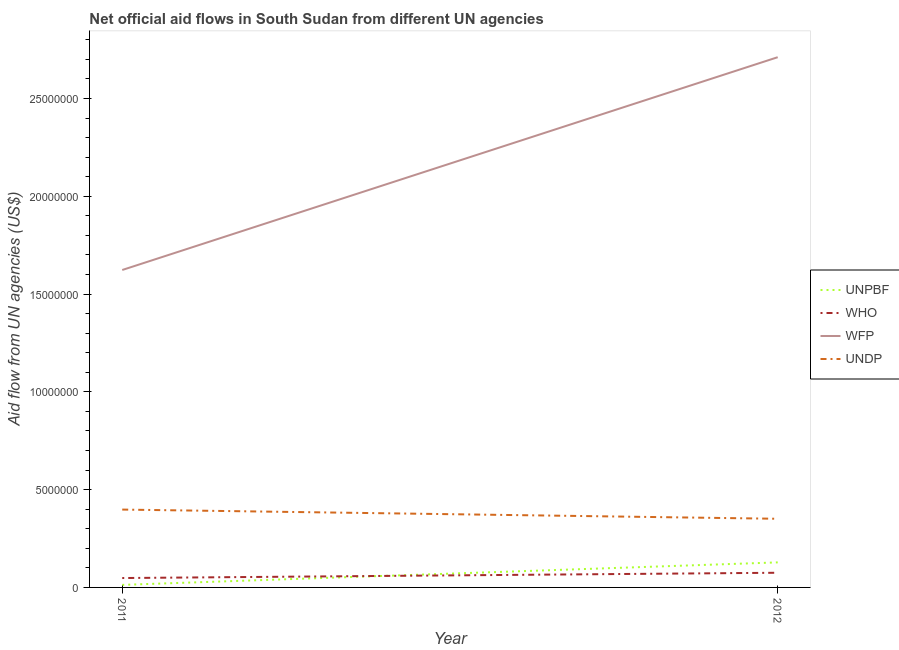How many different coloured lines are there?
Offer a very short reply. 4. What is the amount of aid given by undp in 2011?
Your answer should be very brief. 3.98e+06. Across all years, what is the maximum amount of aid given by unpbf?
Your answer should be very brief. 1.28e+06. Across all years, what is the minimum amount of aid given by who?
Offer a terse response. 4.80e+05. In which year was the amount of aid given by unpbf minimum?
Ensure brevity in your answer.  2011. What is the total amount of aid given by undp in the graph?
Provide a succinct answer. 7.49e+06. What is the difference between the amount of aid given by unpbf in 2011 and that in 2012?
Your response must be concise. -1.15e+06. What is the difference between the amount of aid given by unpbf in 2011 and the amount of aid given by wfp in 2012?
Your answer should be very brief. -2.70e+07. What is the average amount of aid given by unpbf per year?
Make the answer very short. 7.05e+05. In the year 2012, what is the difference between the amount of aid given by unpbf and amount of aid given by wfp?
Ensure brevity in your answer.  -2.58e+07. In how many years, is the amount of aid given by undp greater than 5000000 US$?
Your answer should be compact. 0. What is the ratio of the amount of aid given by undp in 2011 to that in 2012?
Your answer should be compact. 1.13. Does the amount of aid given by unpbf monotonically increase over the years?
Your response must be concise. Yes. Is the amount of aid given by unpbf strictly greater than the amount of aid given by wfp over the years?
Provide a succinct answer. No. Is the amount of aid given by unpbf strictly less than the amount of aid given by who over the years?
Your response must be concise. No. How many lines are there?
Ensure brevity in your answer.  4. How many years are there in the graph?
Your answer should be compact. 2. Does the graph contain any zero values?
Keep it short and to the point. No. Does the graph contain grids?
Ensure brevity in your answer.  No. Where does the legend appear in the graph?
Offer a very short reply. Center right. How many legend labels are there?
Your answer should be compact. 4. What is the title of the graph?
Offer a terse response. Net official aid flows in South Sudan from different UN agencies. What is the label or title of the Y-axis?
Make the answer very short. Aid flow from UN agencies (US$). What is the Aid flow from UN agencies (US$) of UNPBF in 2011?
Provide a succinct answer. 1.30e+05. What is the Aid flow from UN agencies (US$) of WHO in 2011?
Make the answer very short. 4.80e+05. What is the Aid flow from UN agencies (US$) of WFP in 2011?
Provide a succinct answer. 1.62e+07. What is the Aid flow from UN agencies (US$) of UNDP in 2011?
Provide a short and direct response. 3.98e+06. What is the Aid flow from UN agencies (US$) in UNPBF in 2012?
Offer a terse response. 1.28e+06. What is the Aid flow from UN agencies (US$) of WHO in 2012?
Your answer should be compact. 7.50e+05. What is the Aid flow from UN agencies (US$) of WFP in 2012?
Your answer should be very brief. 2.71e+07. What is the Aid flow from UN agencies (US$) in UNDP in 2012?
Your answer should be very brief. 3.51e+06. Across all years, what is the maximum Aid flow from UN agencies (US$) of UNPBF?
Your answer should be compact. 1.28e+06. Across all years, what is the maximum Aid flow from UN agencies (US$) in WHO?
Offer a terse response. 7.50e+05. Across all years, what is the maximum Aid flow from UN agencies (US$) in WFP?
Your answer should be very brief. 2.71e+07. Across all years, what is the maximum Aid flow from UN agencies (US$) of UNDP?
Make the answer very short. 3.98e+06. Across all years, what is the minimum Aid flow from UN agencies (US$) of WHO?
Offer a terse response. 4.80e+05. Across all years, what is the minimum Aid flow from UN agencies (US$) in WFP?
Your answer should be very brief. 1.62e+07. Across all years, what is the minimum Aid flow from UN agencies (US$) in UNDP?
Give a very brief answer. 3.51e+06. What is the total Aid flow from UN agencies (US$) in UNPBF in the graph?
Ensure brevity in your answer.  1.41e+06. What is the total Aid flow from UN agencies (US$) in WHO in the graph?
Keep it short and to the point. 1.23e+06. What is the total Aid flow from UN agencies (US$) in WFP in the graph?
Your answer should be very brief. 4.33e+07. What is the total Aid flow from UN agencies (US$) in UNDP in the graph?
Ensure brevity in your answer.  7.49e+06. What is the difference between the Aid flow from UN agencies (US$) of UNPBF in 2011 and that in 2012?
Make the answer very short. -1.15e+06. What is the difference between the Aid flow from UN agencies (US$) of WFP in 2011 and that in 2012?
Offer a terse response. -1.09e+07. What is the difference between the Aid flow from UN agencies (US$) of UNPBF in 2011 and the Aid flow from UN agencies (US$) of WHO in 2012?
Your response must be concise. -6.20e+05. What is the difference between the Aid flow from UN agencies (US$) of UNPBF in 2011 and the Aid flow from UN agencies (US$) of WFP in 2012?
Make the answer very short. -2.70e+07. What is the difference between the Aid flow from UN agencies (US$) in UNPBF in 2011 and the Aid flow from UN agencies (US$) in UNDP in 2012?
Offer a very short reply. -3.38e+06. What is the difference between the Aid flow from UN agencies (US$) of WHO in 2011 and the Aid flow from UN agencies (US$) of WFP in 2012?
Offer a very short reply. -2.66e+07. What is the difference between the Aid flow from UN agencies (US$) in WHO in 2011 and the Aid flow from UN agencies (US$) in UNDP in 2012?
Keep it short and to the point. -3.03e+06. What is the difference between the Aid flow from UN agencies (US$) in WFP in 2011 and the Aid flow from UN agencies (US$) in UNDP in 2012?
Make the answer very short. 1.27e+07. What is the average Aid flow from UN agencies (US$) in UNPBF per year?
Keep it short and to the point. 7.05e+05. What is the average Aid flow from UN agencies (US$) of WHO per year?
Provide a succinct answer. 6.15e+05. What is the average Aid flow from UN agencies (US$) in WFP per year?
Offer a very short reply. 2.17e+07. What is the average Aid flow from UN agencies (US$) in UNDP per year?
Make the answer very short. 3.74e+06. In the year 2011, what is the difference between the Aid flow from UN agencies (US$) in UNPBF and Aid flow from UN agencies (US$) in WHO?
Make the answer very short. -3.50e+05. In the year 2011, what is the difference between the Aid flow from UN agencies (US$) in UNPBF and Aid flow from UN agencies (US$) in WFP?
Give a very brief answer. -1.61e+07. In the year 2011, what is the difference between the Aid flow from UN agencies (US$) of UNPBF and Aid flow from UN agencies (US$) of UNDP?
Ensure brevity in your answer.  -3.85e+06. In the year 2011, what is the difference between the Aid flow from UN agencies (US$) of WHO and Aid flow from UN agencies (US$) of WFP?
Your answer should be compact. -1.58e+07. In the year 2011, what is the difference between the Aid flow from UN agencies (US$) in WHO and Aid flow from UN agencies (US$) in UNDP?
Keep it short and to the point. -3.50e+06. In the year 2011, what is the difference between the Aid flow from UN agencies (US$) of WFP and Aid flow from UN agencies (US$) of UNDP?
Ensure brevity in your answer.  1.22e+07. In the year 2012, what is the difference between the Aid flow from UN agencies (US$) in UNPBF and Aid flow from UN agencies (US$) in WHO?
Make the answer very short. 5.30e+05. In the year 2012, what is the difference between the Aid flow from UN agencies (US$) of UNPBF and Aid flow from UN agencies (US$) of WFP?
Your answer should be very brief. -2.58e+07. In the year 2012, what is the difference between the Aid flow from UN agencies (US$) in UNPBF and Aid flow from UN agencies (US$) in UNDP?
Provide a succinct answer. -2.23e+06. In the year 2012, what is the difference between the Aid flow from UN agencies (US$) in WHO and Aid flow from UN agencies (US$) in WFP?
Your answer should be compact. -2.64e+07. In the year 2012, what is the difference between the Aid flow from UN agencies (US$) in WHO and Aid flow from UN agencies (US$) in UNDP?
Keep it short and to the point. -2.76e+06. In the year 2012, what is the difference between the Aid flow from UN agencies (US$) of WFP and Aid flow from UN agencies (US$) of UNDP?
Your answer should be compact. 2.36e+07. What is the ratio of the Aid flow from UN agencies (US$) in UNPBF in 2011 to that in 2012?
Keep it short and to the point. 0.1. What is the ratio of the Aid flow from UN agencies (US$) in WHO in 2011 to that in 2012?
Provide a succinct answer. 0.64. What is the ratio of the Aid flow from UN agencies (US$) in WFP in 2011 to that in 2012?
Give a very brief answer. 0.6. What is the ratio of the Aid flow from UN agencies (US$) in UNDP in 2011 to that in 2012?
Your response must be concise. 1.13. What is the difference between the highest and the second highest Aid flow from UN agencies (US$) of UNPBF?
Keep it short and to the point. 1.15e+06. What is the difference between the highest and the second highest Aid flow from UN agencies (US$) in WFP?
Provide a short and direct response. 1.09e+07. What is the difference between the highest and the second highest Aid flow from UN agencies (US$) of UNDP?
Ensure brevity in your answer.  4.70e+05. What is the difference between the highest and the lowest Aid flow from UN agencies (US$) of UNPBF?
Make the answer very short. 1.15e+06. What is the difference between the highest and the lowest Aid flow from UN agencies (US$) of WFP?
Your response must be concise. 1.09e+07. What is the difference between the highest and the lowest Aid flow from UN agencies (US$) of UNDP?
Provide a succinct answer. 4.70e+05. 